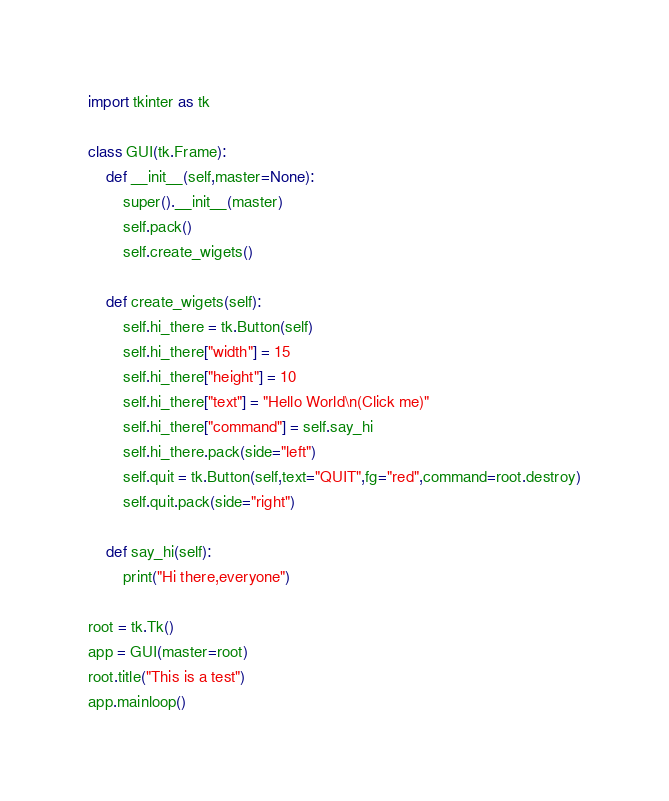<code> <loc_0><loc_0><loc_500><loc_500><_Python_>import tkinter as tk

class GUI(tk.Frame):
    def __init__(self,master=None):
        super().__init__(master)
        self.pack()
        self.create_wigets()
    
    def create_wigets(self):
        self.hi_there = tk.Button(self)
        self.hi_there["width"] = 15
        self.hi_there["height"] = 10
        self.hi_there["text"] = "Hello World\n(Click me)"
        self.hi_there["command"] = self.say_hi
        self.hi_there.pack(side="left")
        self.quit = tk.Button(self,text="QUIT",fg="red",command=root.destroy)
        self.quit.pack(side="right")

    def say_hi(self):
        print("Hi there,everyone")

root = tk.Tk()
app = GUI(master=root)
root.title("This is a test")
app.mainloop()
</code> 